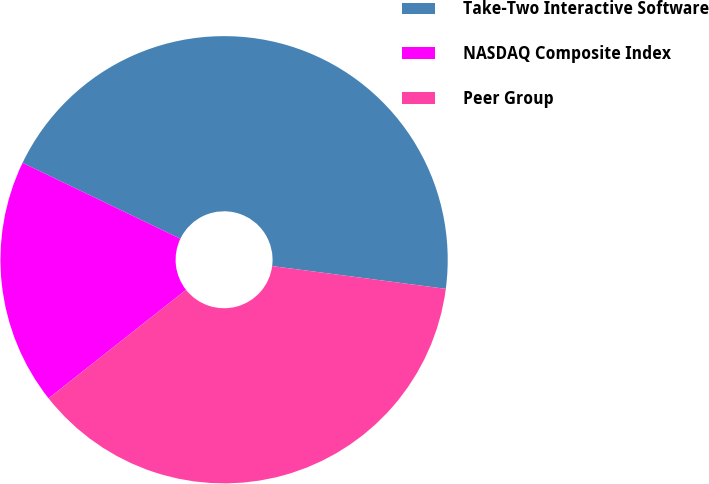Convert chart to OTSL. <chart><loc_0><loc_0><loc_500><loc_500><pie_chart><fcel>Take-Two Interactive Software<fcel>NASDAQ Composite Index<fcel>Peer Group<nl><fcel>44.95%<fcel>17.77%<fcel>37.29%<nl></chart> 